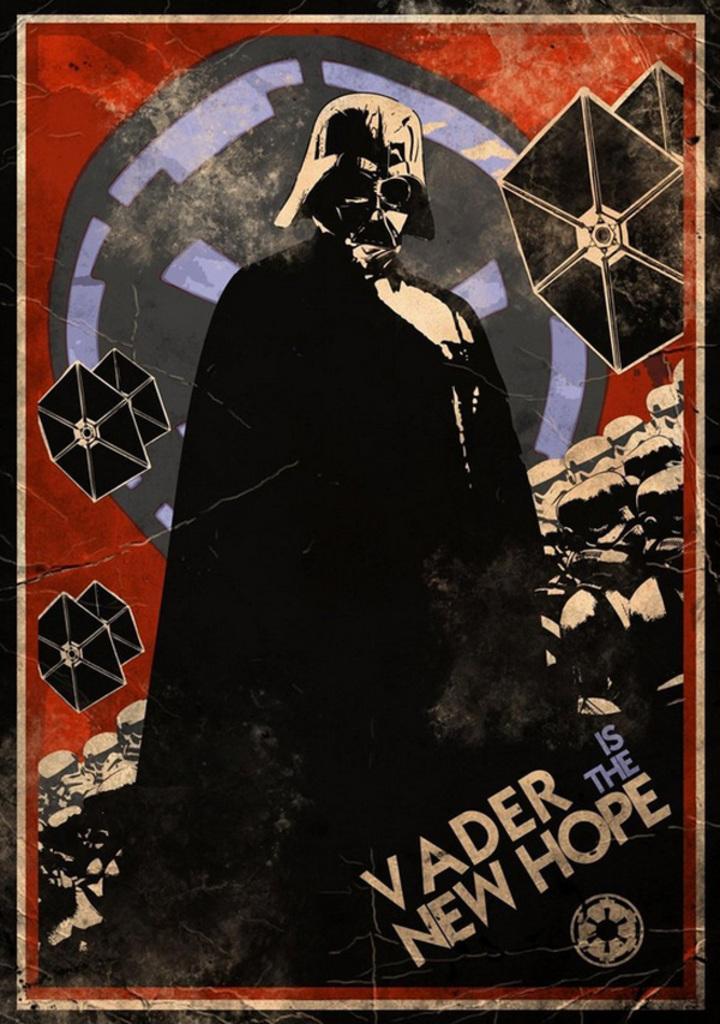Describe this image in one or two sentences. This might be a poster, in this image in the center there is one person who is wearing a hat and goggles. And in the background there are some objects, at the bottom of the image there is text and in the background there is a logo. 